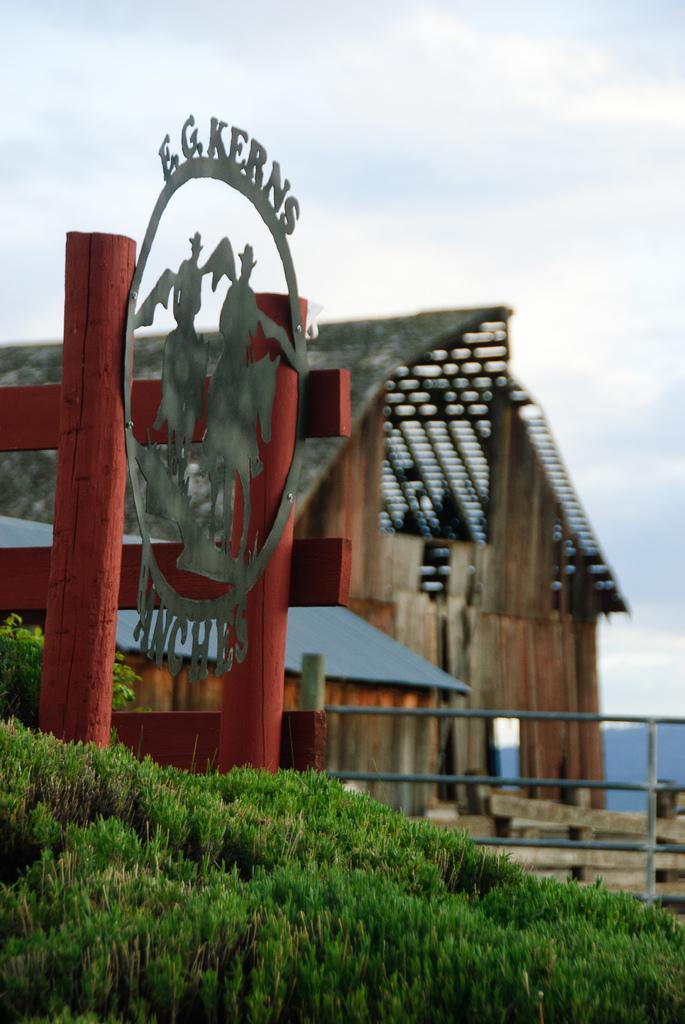Could you give a brief overview of what you see in this image? In this picture we can see the grass, fence, shed, board with the name and in the background we can see the sky with clouds. 